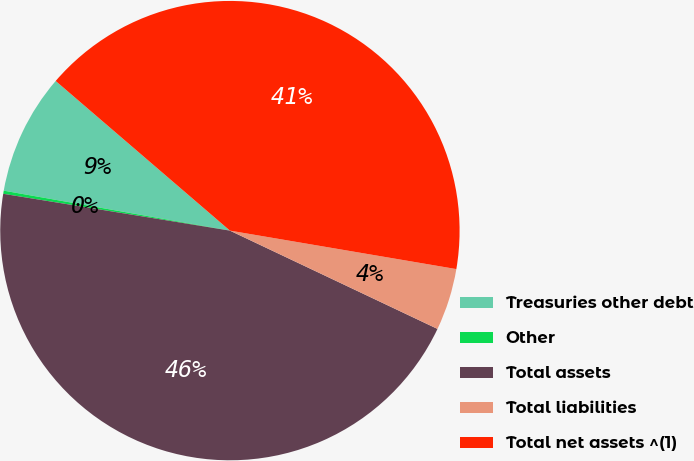Convert chart to OTSL. <chart><loc_0><loc_0><loc_500><loc_500><pie_chart><fcel>Treasuries other debt<fcel>Other<fcel>Total assets<fcel>Total liabilities<fcel>Total net assets ^(1)<nl><fcel>8.51%<fcel>0.22%<fcel>45.52%<fcel>4.36%<fcel>41.38%<nl></chart> 